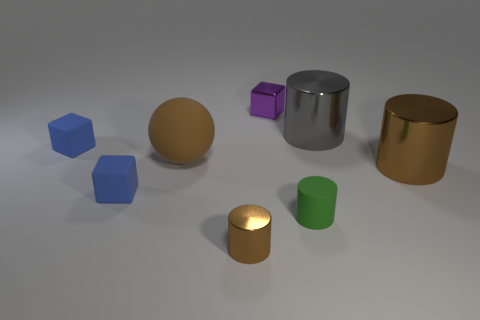The matte sphere that is the same color as the small shiny cylinder is what size?
Offer a very short reply. Large. Are there the same number of tiny brown metallic things in front of the small brown cylinder and small metal cylinders that are behind the small purple shiny cube?
Your response must be concise. Yes. What material is the gray thing?
Your response must be concise. Metal. What is the cylinder to the left of the purple object made of?
Provide a succinct answer. Metal. Is there any other thing that is the same material as the big gray thing?
Make the answer very short. Yes. Are there more big matte balls to the right of the tiny metal cube than green rubber cylinders?
Provide a succinct answer. No. Is there a gray metal thing that is in front of the small rubber block that is behind the object that is to the right of the gray object?
Your answer should be very brief. No. There is a purple metal cube; are there any brown metal cylinders on the left side of it?
Give a very brief answer. Yes. What number of other cylinders are the same color as the tiny metal cylinder?
Your response must be concise. 1. The purple object that is the same material as the small brown object is what size?
Provide a succinct answer. Small. 